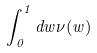Convert formula to latex. <formula><loc_0><loc_0><loc_500><loc_500>\int _ { 0 } ^ { 1 } d w \nu ( w )</formula> 